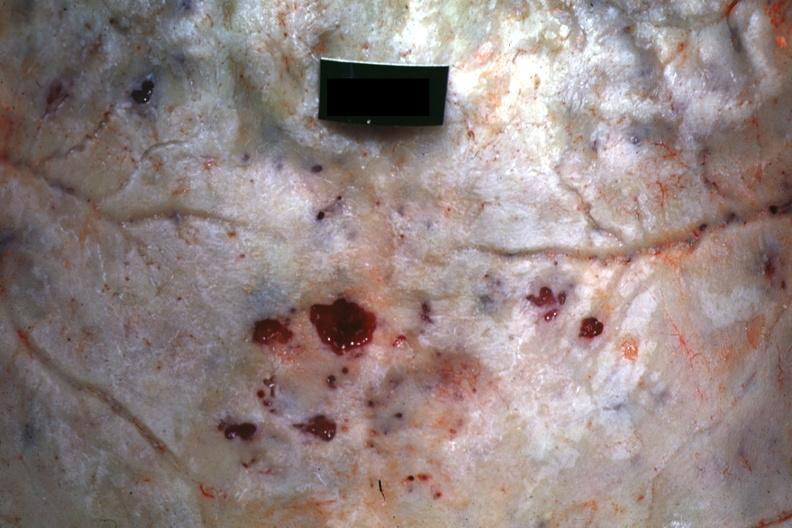does this image show close-up view of hemorrhagic excavation quite good?
Answer the question using a single word or phrase. Yes 